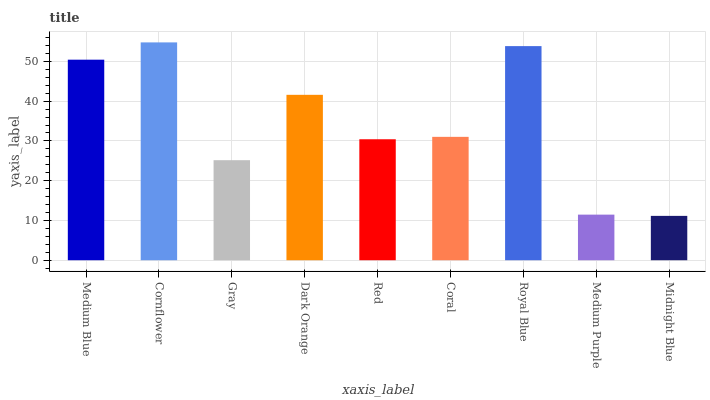Is Midnight Blue the minimum?
Answer yes or no. Yes. Is Cornflower the maximum?
Answer yes or no. Yes. Is Gray the minimum?
Answer yes or no. No. Is Gray the maximum?
Answer yes or no. No. Is Cornflower greater than Gray?
Answer yes or no. Yes. Is Gray less than Cornflower?
Answer yes or no. Yes. Is Gray greater than Cornflower?
Answer yes or no. No. Is Cornflower less than Gray?
Answer yes or no. No. Is Coral the high median?
Answer yes or no. Yes. Is Coral the low median?
Answer yes or no. Yes. Is Red the high median?
Answer yes or no. No. Is Red the low median?
Answer yes or no. No. 